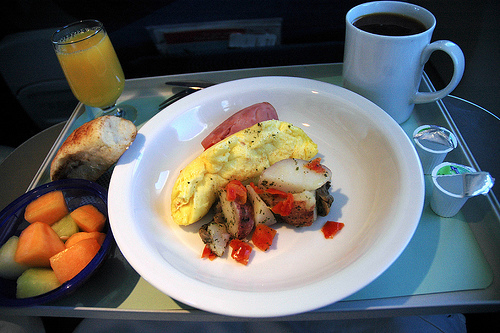<image>
Is there a plate on the table? Yes. Looking at the image, I can see the plate is positioned on top of the table, with the table providing support. Is there a bowl under the food? Yes. The bowl is positioned underneath the food, with the food above it in the vertical space. 